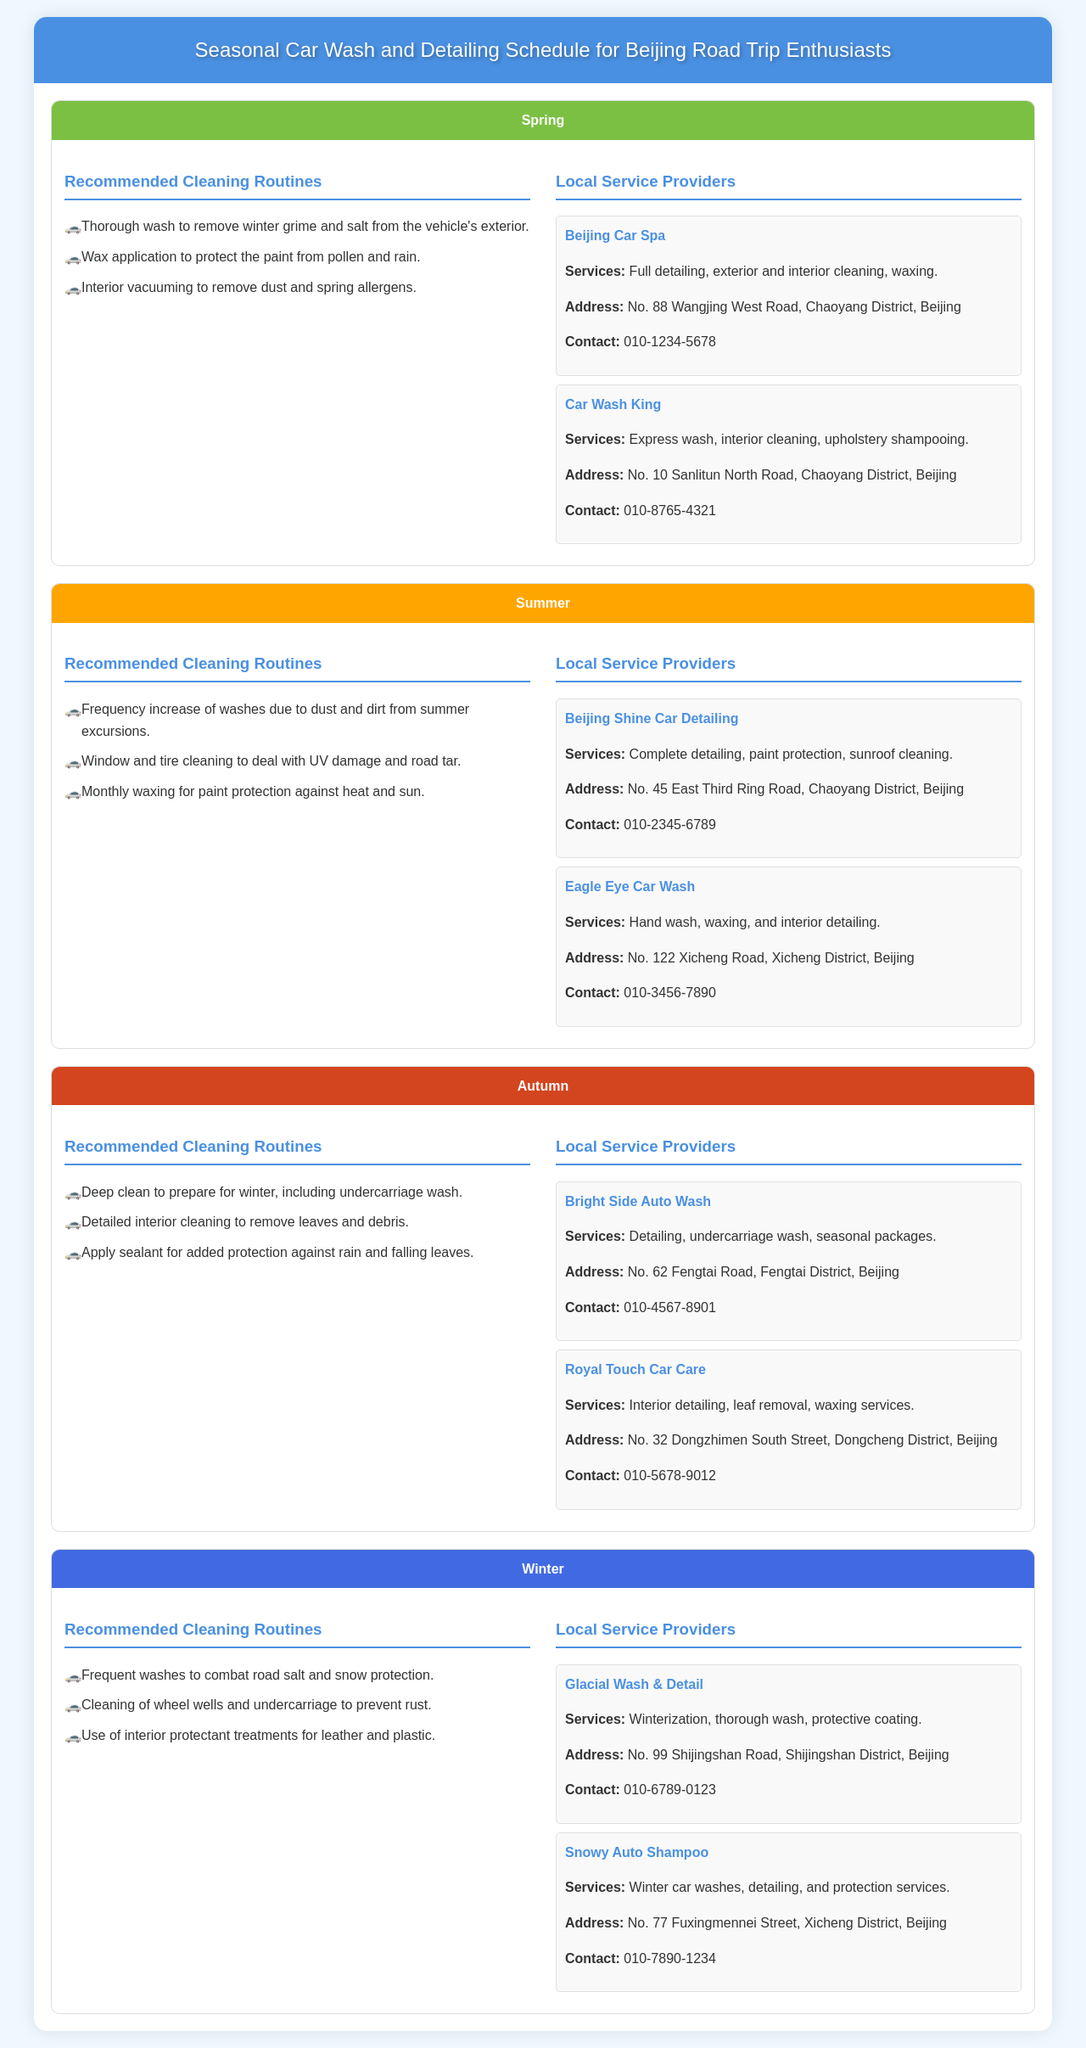What are the recommended cleaning routines for spring? The document lists specific cleaning routines for each season, including spring routines.
Answer: Thorough wash to remove winter grime and salt from the vehicle's exterior. Wax application to protect the paint from pollen and rain. Interior vacuuming to remove dust and spring allergens How often should waxing be done in summer? The document mentions the recommended frequency for waxing during summer cleaning routines.
Answer: Monthly waxing What is the contact number for Beijing Shine Car Detailing? The document provides contact information for local service providers, including Beijing Shine Car Detailing.
Answer: 010-2345-6789 Which provider offers winterization services? The document contains information about local providers and their services, identifying those that provide winter-specific services.
Answer: Glacial Wash & Detail What is the address of Royal Touch Car Care? The document provides specific addresses for each local service provider, including Royal Touch Car Care.
Answer: No. 32 Dongzhimen South Street, Dongcheng District, Beijing What is the main purpose of the document? The document is structured to provide a seasonal schedule for car wash and detailing, outlining routines and service providers.
Answer: Seasonal Car Wash and Detailing Schedule for Beijing Road Trip Enthusiasts What type of cleaning is recommended before winter? The document specifies seasonal routines including the recommended cleaning type for autumn to prepare for winter.
Answer: Deep clean to prepare for winter, including undercarriage wash How many local service providers are listed for summer? The document specifies the number of service providers under the summer section.
Answer: Two local service providers 